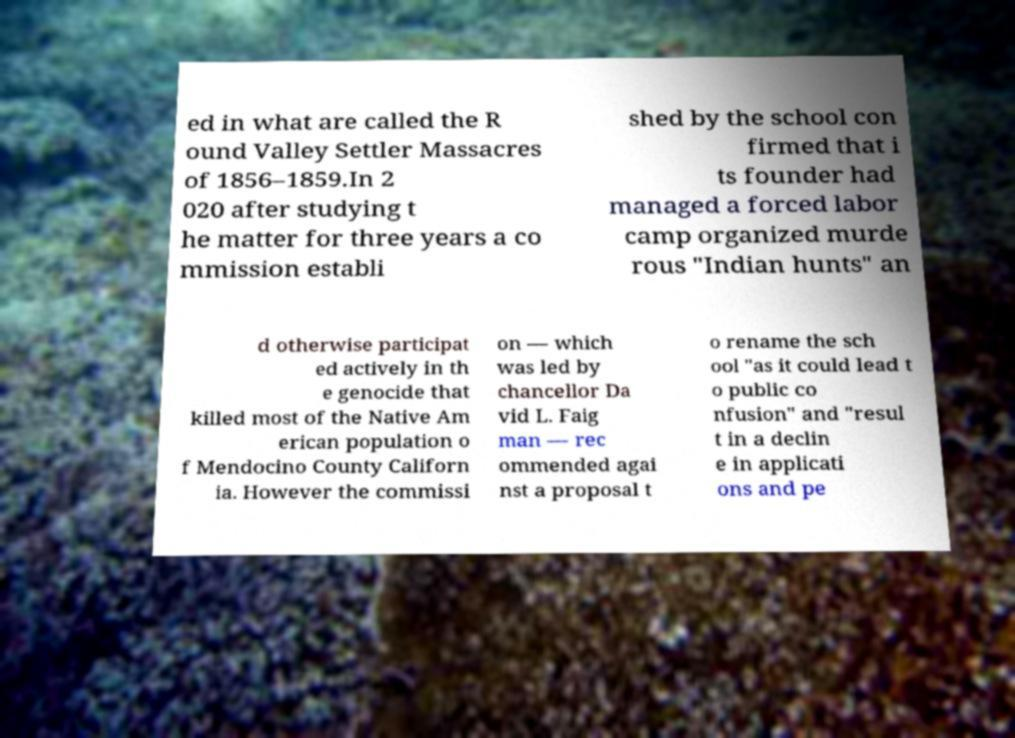There's text embedded in this image that I need extracted. Can you transcribe it verbatim? ed in what are called the R ound Valley Settler Massacres of 1856–1859.In 2 020 after studying t he matter for three years a co mmission establi shed by the school con firmed that i ts founder had managed a forced labor camp organized murde rous "Indian hunts" an d otherwise participat ed actively in th e genocide that killed most of the Native Am erican population o f Mendocino County Californ ia. However the commissi on — which was led by chancellor Da vid L. Faig man — rec ommended agai nst a proposal t o rename the sch ool "as it could lead t o public co nfusion" and "resul t in a declin e in applicati ons and pe 